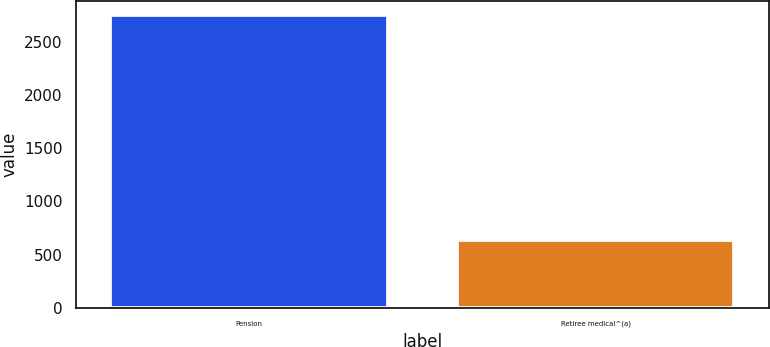Convert chart to OTSL. <chart><loc_0><loc_0><loc_500><loc_500><bar_chart><fcel>Pension<fcel>Retiree medical^(a)<nl><fcel>2755<fcel>640<nl></chart> 